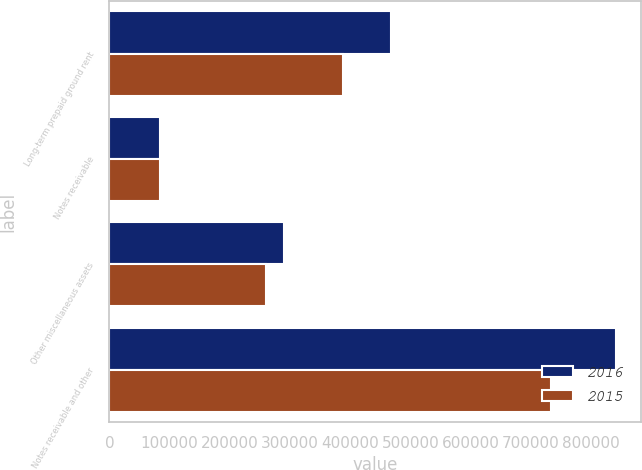Convert chart to OTSL. <chart><loc_0><loc_0><loc_500><loc_500><stacked_bar_chart><ecel><fcel>Long-term prepaid ground rent<fcel>Notes receivable<fcel>Other miscellaneous assets<fcel>Notes receivable and other<nl><fcel>2016<fcel>467781<fcel>83736<fcel>290006<fcel>841523<nl><fcel>2015<fcel>388790<fcel>83658<fcel>260455<fcel>732903<nl></chart> 